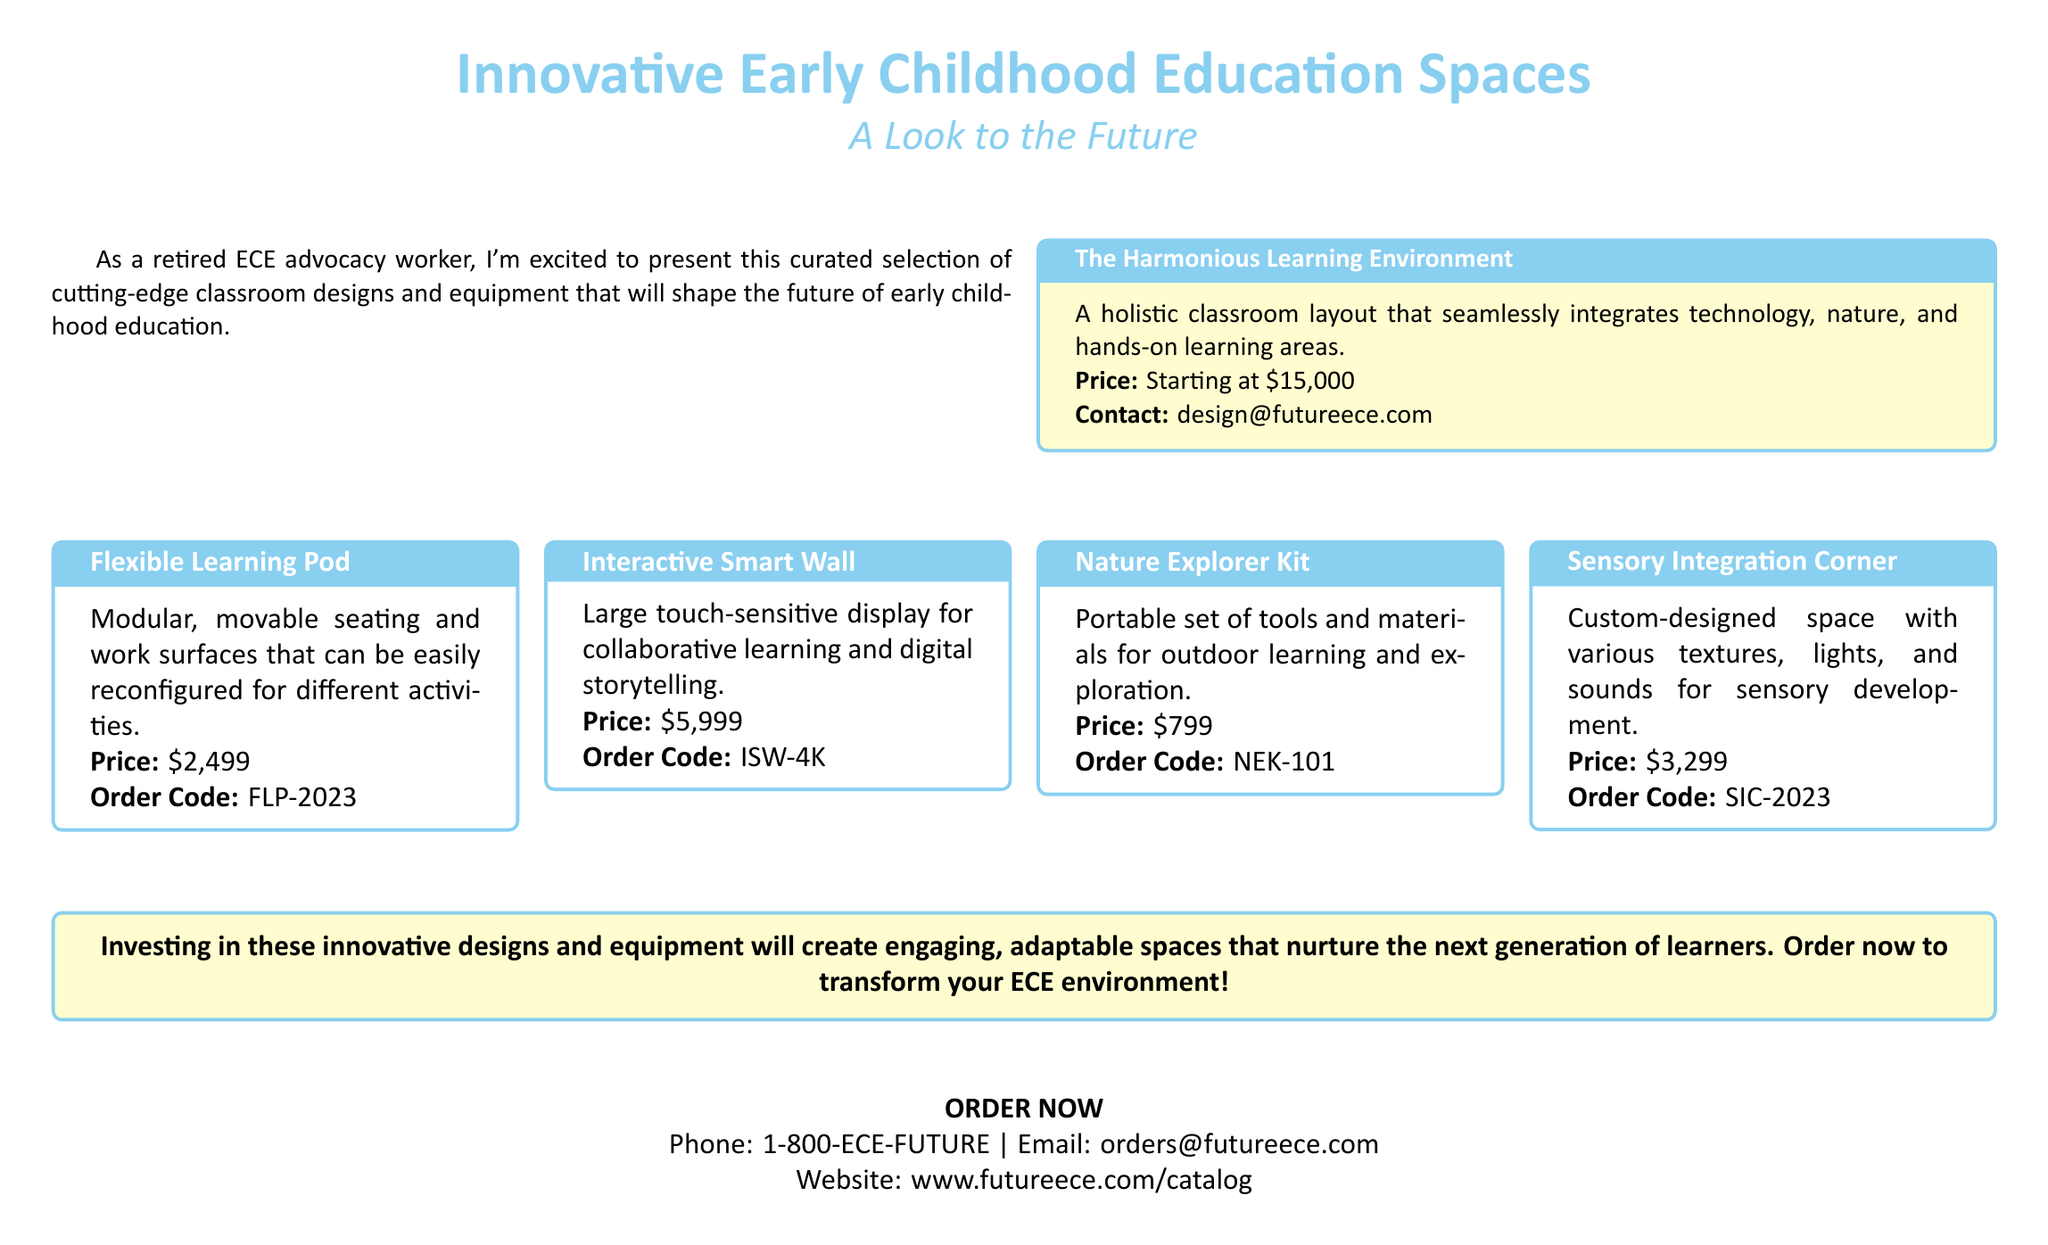What is the starting price of the Harmonious Learning Environment? The price mentioned for the Harmonious Learning Environment in the document is starting at $15,000.
Answer: $15,000 What is the order code for the Flexible Learning Pod? The document specifies the order code for the Flexible Learning Pod as FLP-2023.
Answer: FLP-2023 How much does the Nature Explorer Kit cost? The document states that the Nature Explorer Kit is priced at $799.
Answer: $799 What is the price of the Interactive Smart Wall? The price listed for the Interactive Smart Wall in the document is $5,999.
Answer: $5,999 Which product is designed for sensory development? The document highlights the Sensory Integration Corner as designed for sensory development.
Answer: Sensory Integration Corner If you want to order equipment, what email should you contact? The document provides the email order address as orders@futureece.com for orders.
Answer: orders@futureece.com What type of classroom layout does the Harmonious Learning Environment provide? The document describes the Harmonious Learning Environment as a holistic classroom layout.
Answer: Holistic classroom layout Which product offers modular seating? The document mentions the Flexible Learning Pod as offering modular seating.
Answer: Flexible Learning Pod What is the phone number to order now? The document gives the phone number for ordering as 1-800-ECE-FUTURE.
Answer: 1-800-ECE-FUTURE 